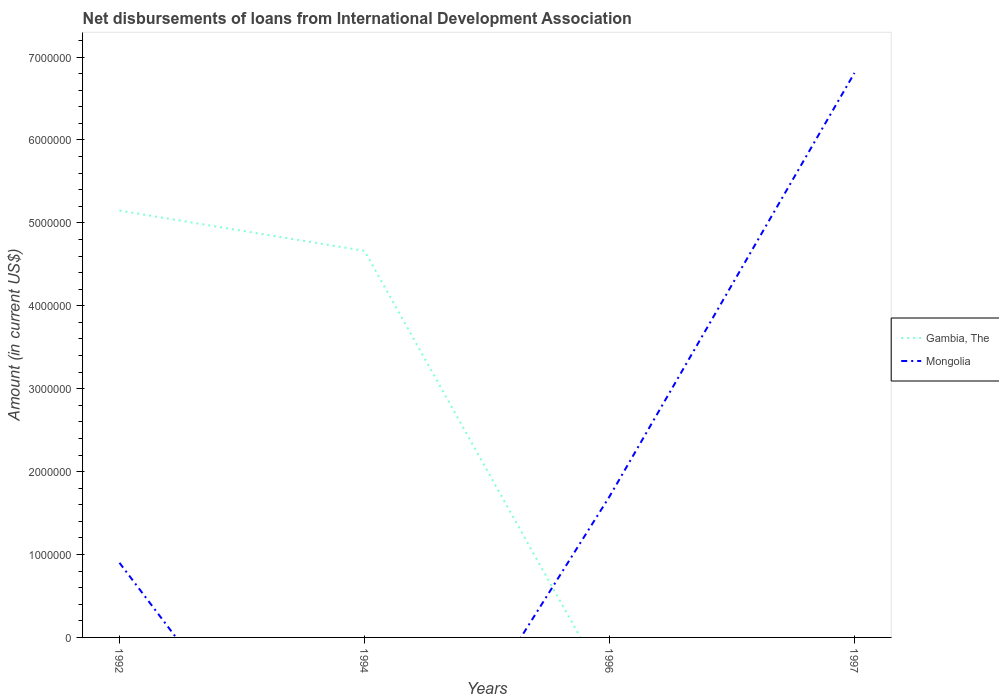How many different coloured lines are there?
Make the answer very short. 2. Does the line corresponding to Gambia, The intersect with the line corresponding to Mongolia?
Ensure brevity in your answer.  Yes. What is the total amount of loans disbursed in Mongolia in the graph?
Ensure brevity in your answer.  -5.91e+06. What is the difference between the highest and the second highest amount of loans disbursed in Mongolia?
Your answer should be very brief. 6.81e+06. Is the amount of loans disbursed in Mongolia strictly greater than the amount of loans disbursed in Gambia, The over the years?
Give a very brief answer. No. How many lines are there?
Give a very brief answer. 2. Are the values on the major ticks of Y-axis written in scientific E-notation?
Keep it short and to the point. No. Does the graph contain any zero values?
Your response must be concise. Yes. What is the title of the graph?
Your response must be concise. Net disbursements of loans from International Development Association. Does "Togo" appear as one of the legend labels in the graph?
Ensure brevity in your answer.  No. What is the label or title of the X-axis?
Your response must be concise. Years. What is the label or title of the Y-axis?
Your response must be concise. Amount (in current US$). What is the Amount (in current US$) in Gambia, The in 1992?
Provide a short and direct response. 5.15e+06. What is the Amount (in current US$) in Gambia, The in 1994?
Provide a short and direct response. 4.66e+06. What is the Amount (in current US$) of Mongolia in 1994?
Provide a succinct answer. 0. What is the Amount (in current US$) of Gambia, The in 1996?
Give a very brief answer. 0. What is the Amount (in current US$) of Mongolia in 1996?
Offer a very short reply. 1.70e+06. What is the Amount (in current US$) in Gambia, The in 1997?
Make the answer very short. 0. What is the Amount (in current US$) in Mongolia in 1997?
Your answer should be compact. 6.81e+06. Across all years, what is the maximum Amount (in current US$) of Gambia, The?
Keep it short and to the point. 5.15e+06. Across all years, what is the maximum Amount (in current US$) in Mongolia?
Make the answer very short. 6.81e+06. Across all years, what is the minimum Amount (in current US$) in Gambia, The?
Your answer should be compact. 0. What is the total Amount (in current US$) of Gambia, The in the graph?
Give a very brief answer. 9.81e+06. What is the total Amount (in current US$) in Mongolia in the graph?
Your answer should be compact. 9.41e+06. What is the difference between the Amount (in current US$) in Gambia, The in 1992 and that in 1994?
Give a very brief answer. 4.85e+05. What is the difference between the Amount (in current US$) of Mongolia in 1992 and that in 1996?
Provide a succinct answer. -7.99e+05. What is the difference between the Amount (in current US$) of Mongolia in 1992 and that in 1997?
Provide a short and direct response. -5.91e+06. What is the difference between the Amount (in current US$) of Mongolia in 1996 and that in 1997?
Keep it short and to the point. -5.11e+06. What is the difference between the Amount (in current US$) of Gambia, The in 1992 and the Amount (in current US$) of Mongolia in 1996?
Offer a terse response. 3.45e+06. What is the difference between the Amount (in current US$) of Gambia, The in 1992 and the Amount (in current US$) of Mongolia in 1997?
Your answer should be very brief. -1.66e+06. What is the difference between the Amount (in current US$) of Gambia, The in 1994 and the Amount (in current US$) of Mongolia in 1996?
Offer a terse response. 2.96e+06. What is the difference between the Amount (in current US$) of Gambia, The in 1994 and the Amount (in current US$) of Mongolia in 1997?
Provide a short and direct response. -2.15e+06. What is the average Amount (in current US$) of Gambia, The per year?
Offer a terse response. 2.45e+06. What is the average Amount (in current US$) of Mongolia per year?
Offer a terse response. 2.35e+06. In the year 1992, what is the difference between the Amount (in current US$) of Gambia, The and Amount (in current US$) of Mongolia?
Offer a very short reply. 4.25e+06. What is the ratio of the Amount (in current US$) of Gambia, The in 1992 to that in 1994?
Make the answer very short. 1.1. What is the ratio of the Amount (in current US$) in Mongolia in 1992 to that in 1996?
Your answer should be very brief. 0.53. What is the ratio of the Amount (in current US$) in Mongolia in 1992 to that in 1997?
Keep it short and to the point. 0.13. What is the ratio of the Amount (in current US$) in Mongolia in 1996 to that in 1997?
Keep it short and to the point. 0.25. What is the difference between the highest and the second highest Amount (in current US$) in Mongolia?
Provide a succinct answer. 5.11e+06. What is the difference between the highest and the lowest Amount (in current US$) in Gambia, The?
Your answer should be compact. 5.15e+06. What is the difference between the highest and the lowest Amount (in current US$) of Mongolia?
Provide a short and direct response. 6.81e+06. 